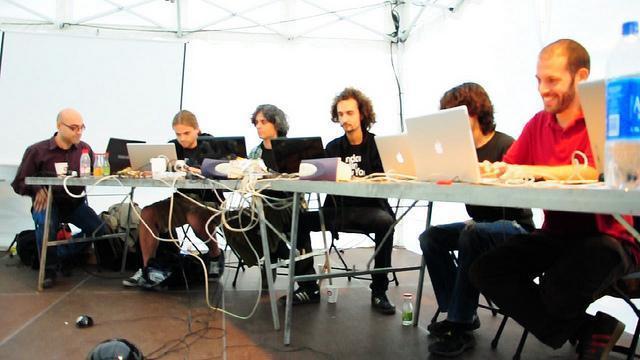How many laptops are visible?
Give a very brief answer. 6. How many laptops are in the photo?
Give a very brief answer. 2. How many people are there?
Give a very brief answer. 6. 